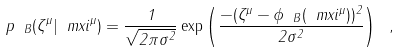Convert formula to latex. <formula><loc_0><loc_0><loc_500><loc_500>p _ { \ B } ( \zeta ^ { \mu } | \ m x i ^ { \mu } ) = \frac { 1 } { \sqrt { 2 \pi \sigma ^ { 2 } } } \exp \left ( \frac { - ( \zeta ^ { \mu } - \phi _ { \ B } ( \ m x i ^ { \mu } ) ) ^ { 2 } } { 2 \sigma ^ { 2 } } \right ) \ ,</formula> 